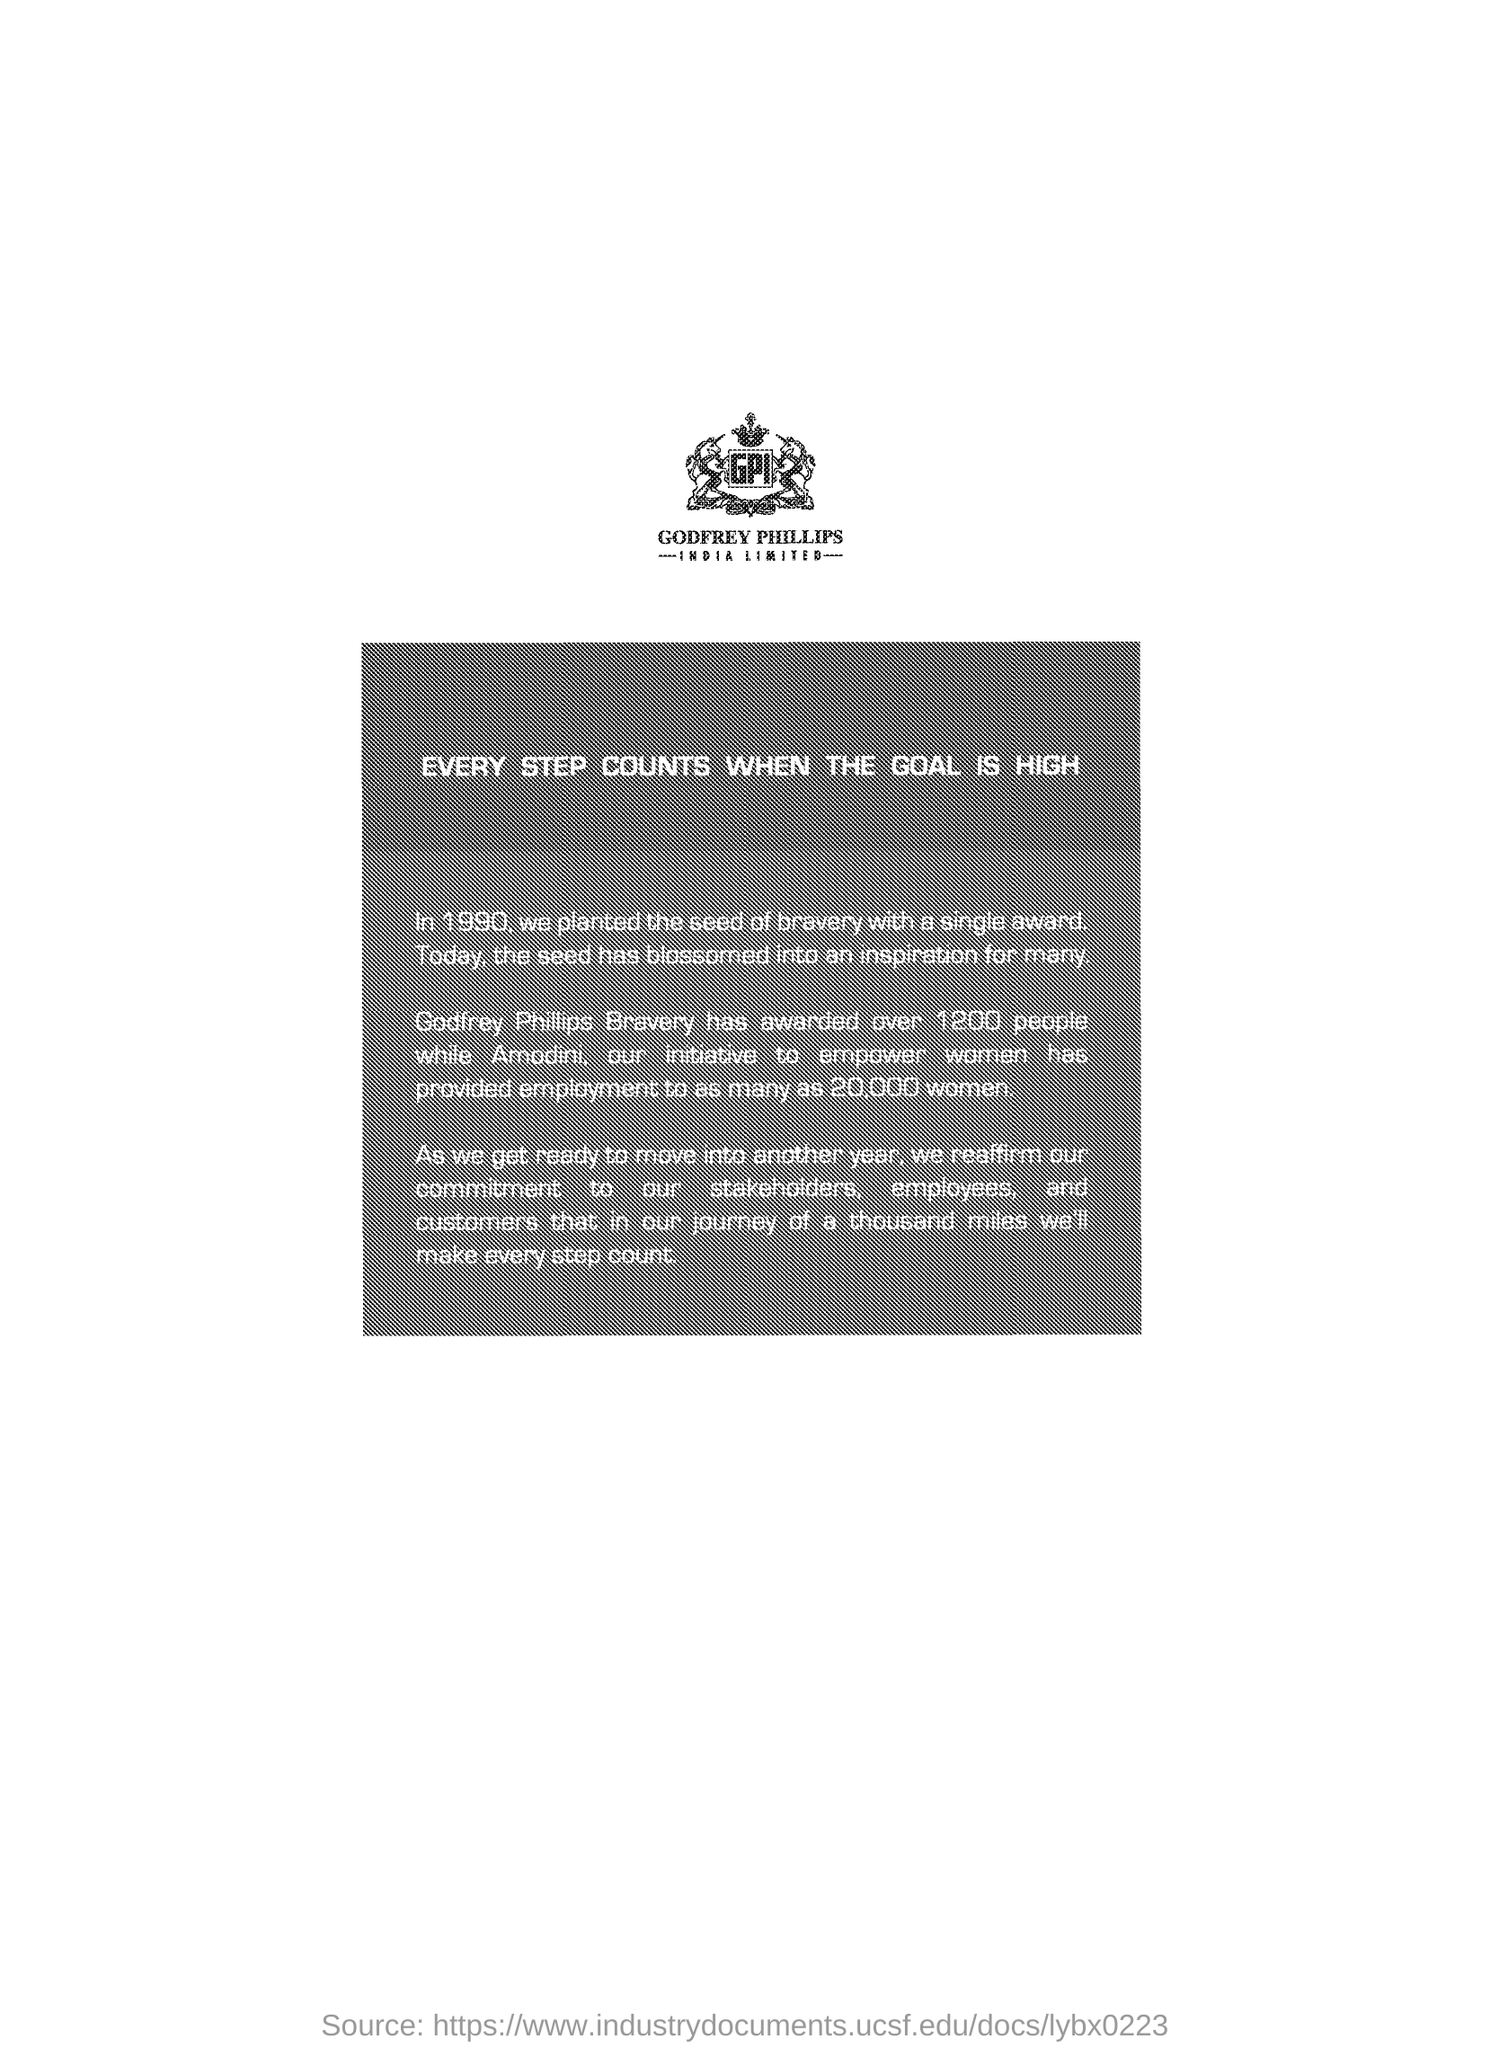List a handful of essential elements in this visual. In the last 5 years, our initiative, "Amodini," has provided employment to 20,000 women, empowering them to improve their economic and social status. In the year 1990, the seed of bravery was planted with a single award. The bravery of Godfrey Phillips has been recognized through the award of over 1200 individuals. 